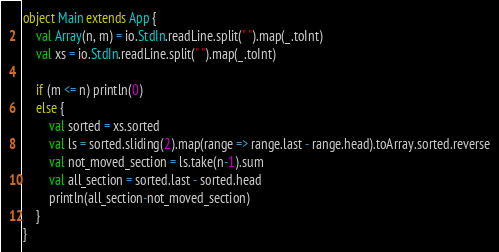<code> <loc_0><loc_0><loc_500><loc_500><_Scala_>object Main extends App {
    val Array(n, m) = io.StdIn.readLine.split(" ").map(_.toInt)
    val xs = io.StdIn.readLine.split(" ").map(_.toInt)

    if (m <= n) println(0)
    else {
        val sorted = xs.sorted
        val ls = sorted.sliding(2).map(range => range.last - range.head).toArray.sorted.reverse
        val not_moved_section = ls.take(n-1).sum
        val all_section = sorted.last - sorted.head
        println(all_section-not_moved_section)
    }
}</code> 